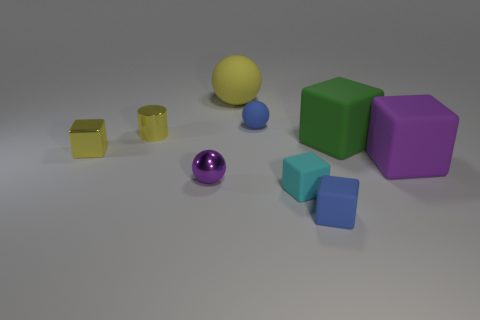What textures are visible in the image, and which objects stand out the most? The textures in the image range from matte to shiny. The yellow cylinder and the purple sphere have shiny, reflective surfaces that stand out due to their bright colors and reflections. The other objects possess a matte finish which makes the light diffuse more evenly across their surfaces, giving a softer appearance. 